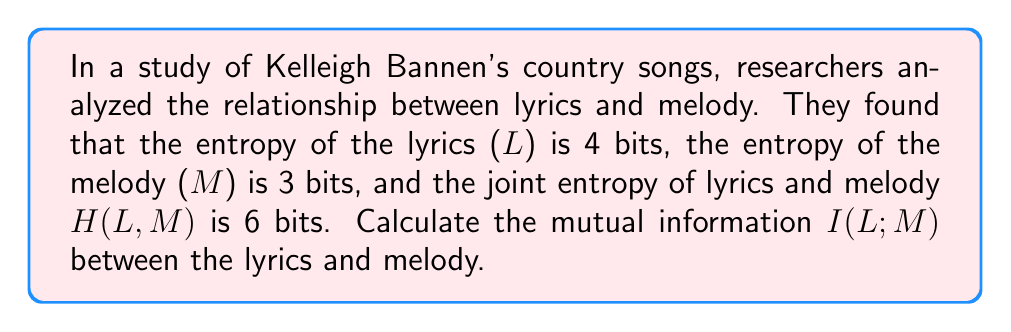Can you answer this question? To solve this problem, we'll use the concept of mutual information from information theory. Mutual information I(L;M) measures the amount of information shared between two random variables, in this case, lyrics (L) and melody (M).

The formula for mutual information is:

$$I(L;M) = H(L) + H(M) - H(L,M)$$

Where:
- $H(L)$ is the entropy of the lyrics
- $H(M)$ is the entropy of the melody
- $H(L,M)$ is the joint entropy of lyrics and melody

Given:
- $H(L) = 4$ bits
- $H(M) = 3$ bits
- $H(L,M) = 6$ bits

Let's substitute these values into the formula:

$$I(L;M) = H(L) + H(M) - H(L,M)$$
$$I(L;M) = 4 + 3 - 6$$
$$I(L;M) = 1$$

Therefore, the mutual information between lyrics and melody in Kelleigh Bannen's country songs is 1 bit.

This result indicates that there is some correlation between the lyrics and melody in her songs. A mutual information of 1 bit suggests that knowing either the lyrics or the melody reduces the uncertainty about the other by 1 bit on average.
Answer: 1 bit 